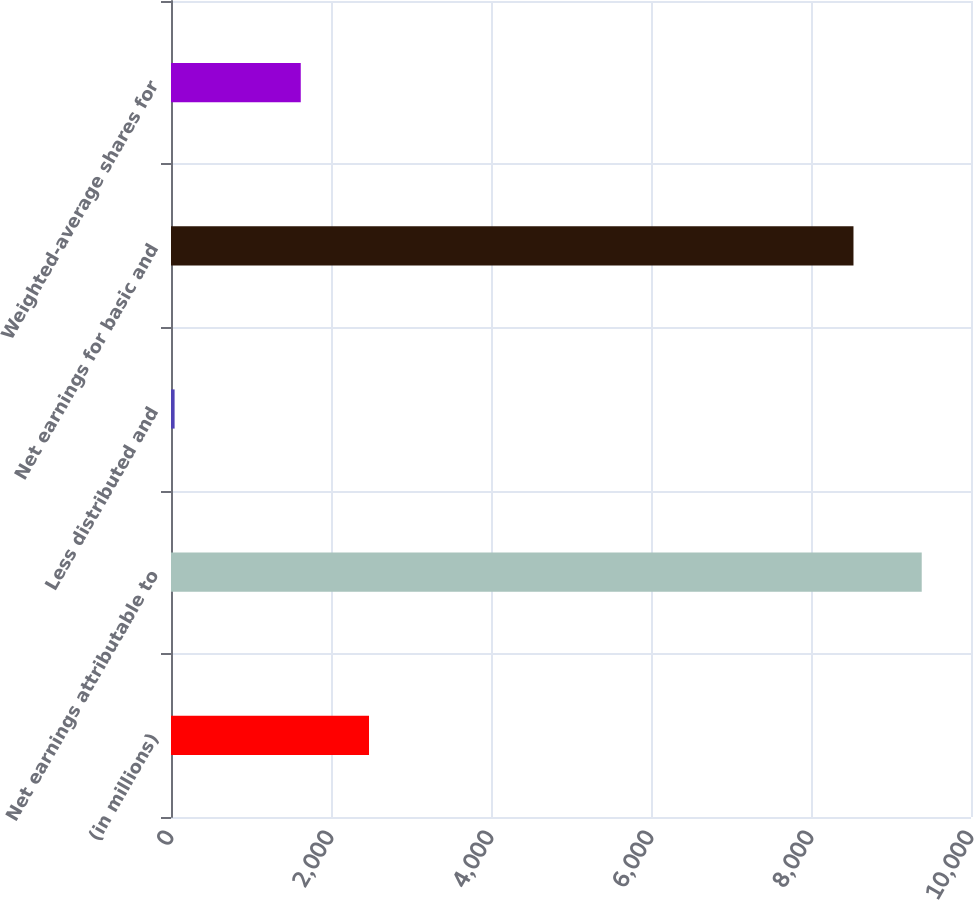<chart> <loc_0><loc_0><loc_500><loc_500><bar_chart><fcel>(in millions)<fcel>Net earnings attributable to<fcel>Less distributed and<fcel>Net earnings for basic and<fcel>Weighted-average shares for<nl><fcel>2475.1<fcel>9384.1<fcel>45<fcel>8531<fcel>1622<nl></chart> 